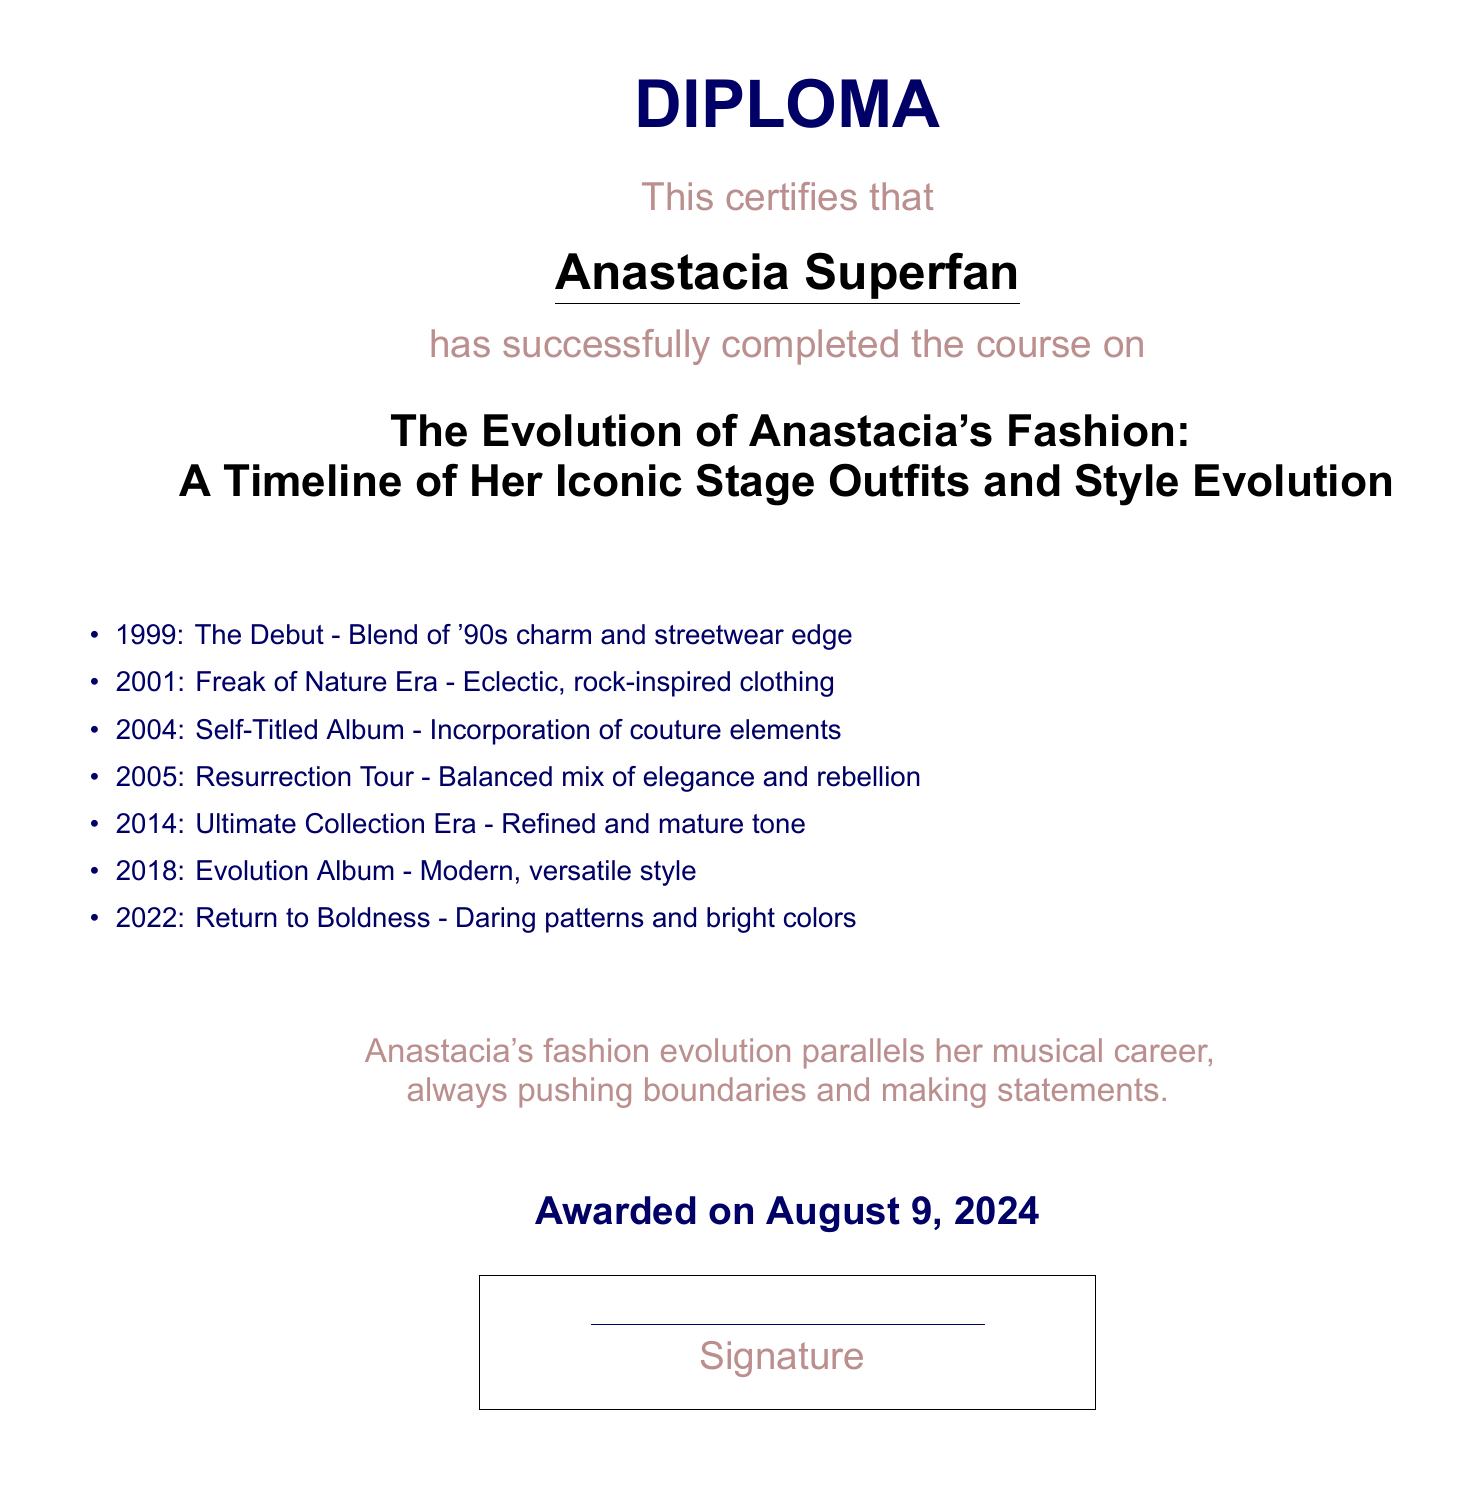What is the title of the course? The title of the course is mentioned prominently in the center of the document under the diploma certification.
Answer: The Evolution of Anastacia's Fashion: A Timeline of Her Iconic Stage Outfits and Style Evolution In what year did Anastacia's fashion debut? The year of Anastacia's debut is listed in the timeline section of the document.
Answer: 1999 Which album's era is characterized by a refined and mature tone? The era of the Ultimate Collection Album includes a description in the timeline that indicates its characteristics.
Answer: Ultimate Collection Era What style is associated with Anastacia's 2004 outfits? The description of her outfits in 2004 indicates a specific style that incorporates certain fashion elements.
Answer: Couture elements How many years passed between the debut and the Resurrection Tour? The years of the debut and Resurrection Tour can be calculated based on the years provided in the timeline.
Answer: 6 years What color theme did Anastacia return to in 2022? The document outlines the main characteristics of her fashion return in 2022, including specific colors.
Answer: Boldness What is the document's issued date? The diploma mentions the date on which it was awarded and is formatted at the bottom center of the document.
Answer: Today's date Which style was prevalent during the Freak of Nature Era? The timeline provides details about the defining style characteristics of the Freak of Nature era.
Answer: Rock-inspired clothing 